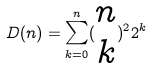Convert formula to latex. <formula><loc_0><loc_0><loc_500><loc_500>D ( n ) = \sum _ { k = 0 } ^ { n } ( \begin{matrix} n \\ k \end{matrix} ) ^ { 2 } 2 ^ { k }</formula> 